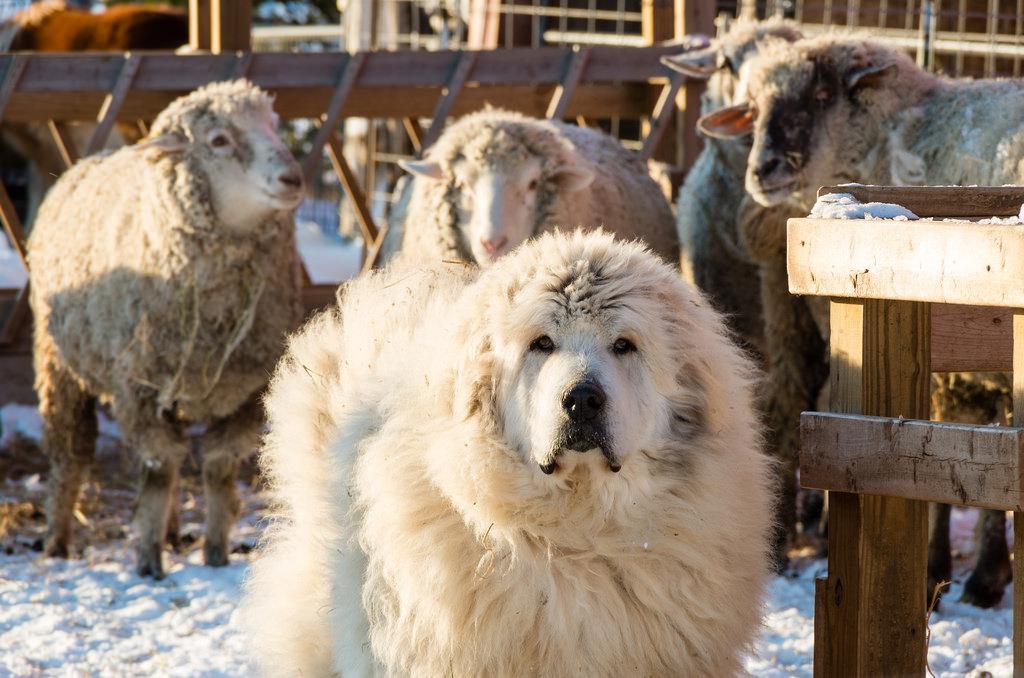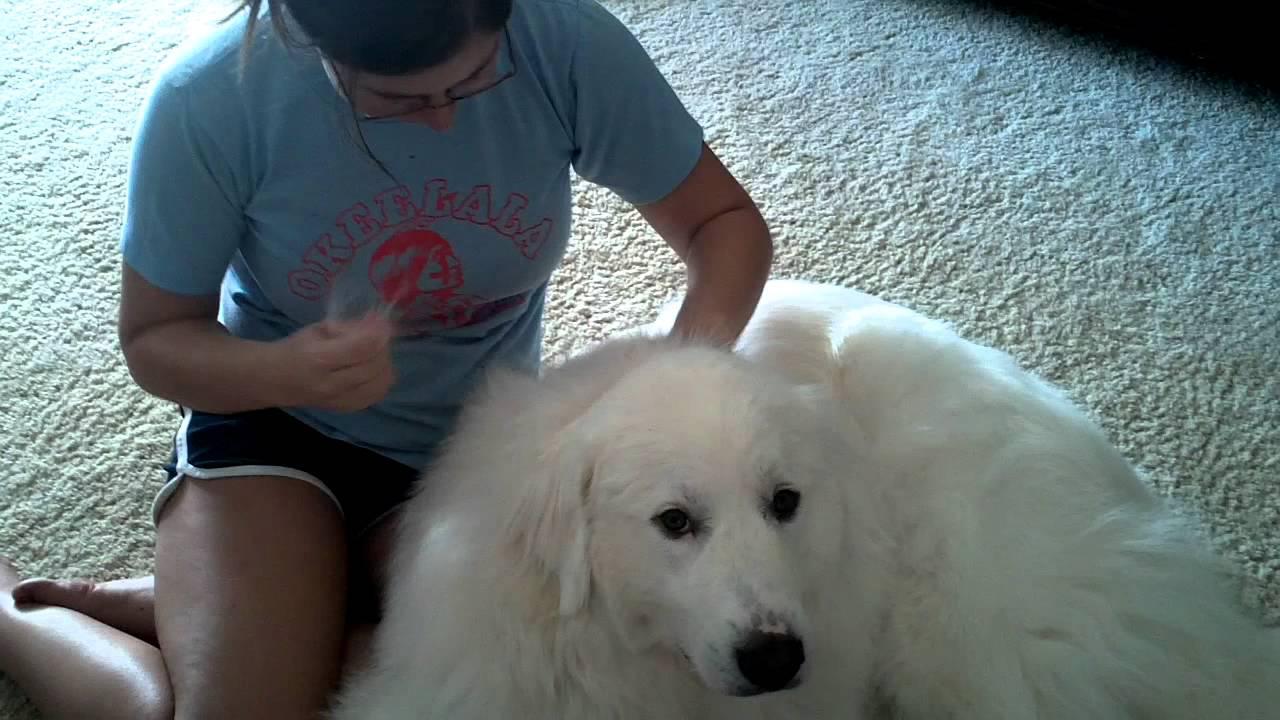The first image is the image on the left, the second image is the image on the right. Evaluate the accuracy of this statement regarding the images: "Atleast one dog is sitting next to a pile of hair.". Is it true? Answer yes or no. No. The first image is the image on the left, the second image is the image on the right. For the images displayed, is the sentence "There are piles of fur on the floor in at least one picture." factually correct? Answer yes or no. No. 